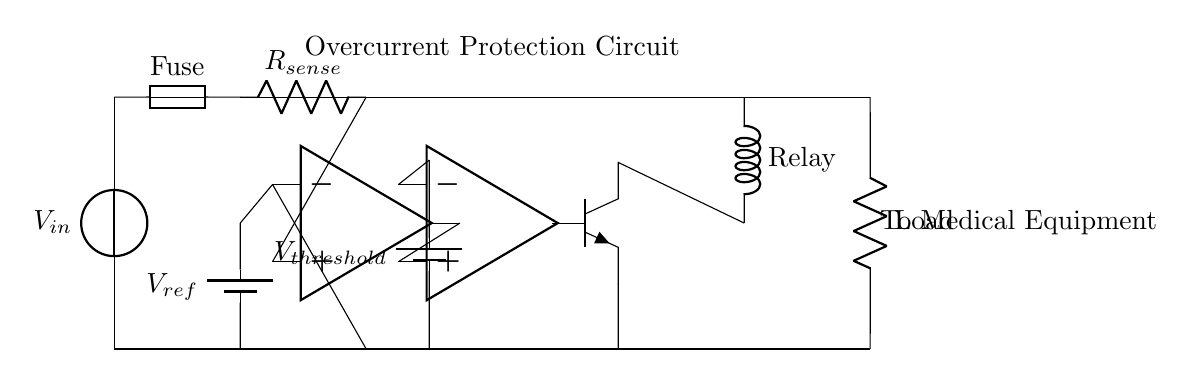What is the input voltage source labeled? The input voltage source in the circuit is labeled as V in. This label indicates where the power enters the circuit.
Answer: V in What component is used for current sensing? The component used for current sensing in the circuit is the resistor labeled R sense. This resistor is placed in series with the load to measure the current flow.
Answer: R sense What is the purpose of the fuse in this circuit? The fuse provides overcurrent protection by breaking the circuit when the current exceeds a certain threshold. This limits damage to the circuit and connected medical equipment.
Answer: Overcurrent protection What component operates as a switch in the circuit? The transistor labeled npn acts as a switch in the circuit. It controls the connection to the relay based on the output from the comparator.
Answer: npn Why is there a reference voltage connected to the operational amplifier? The reference voltage, labeled V ref, is connected to the operational amplifier to set a baseline for comparison against the sensed voltage across R sense. This helps determine if the current is within acceptable limits.
Answer: To set a comparison baseline What is activated if the current exceeds the threshold? If the current exceeds the threshold, the relay will be activated to disconnect the load from the power supply, preventing damage to the medical equipment.
Answer: Relay What does V threshold signify in this circuit? V threshold represents the voltage level that the comparator uses to decide whether to activate the circuit protection mechanism. If the sensed voltage exceeds this level, action will be taken.
Answer: Voltage level for comparison 